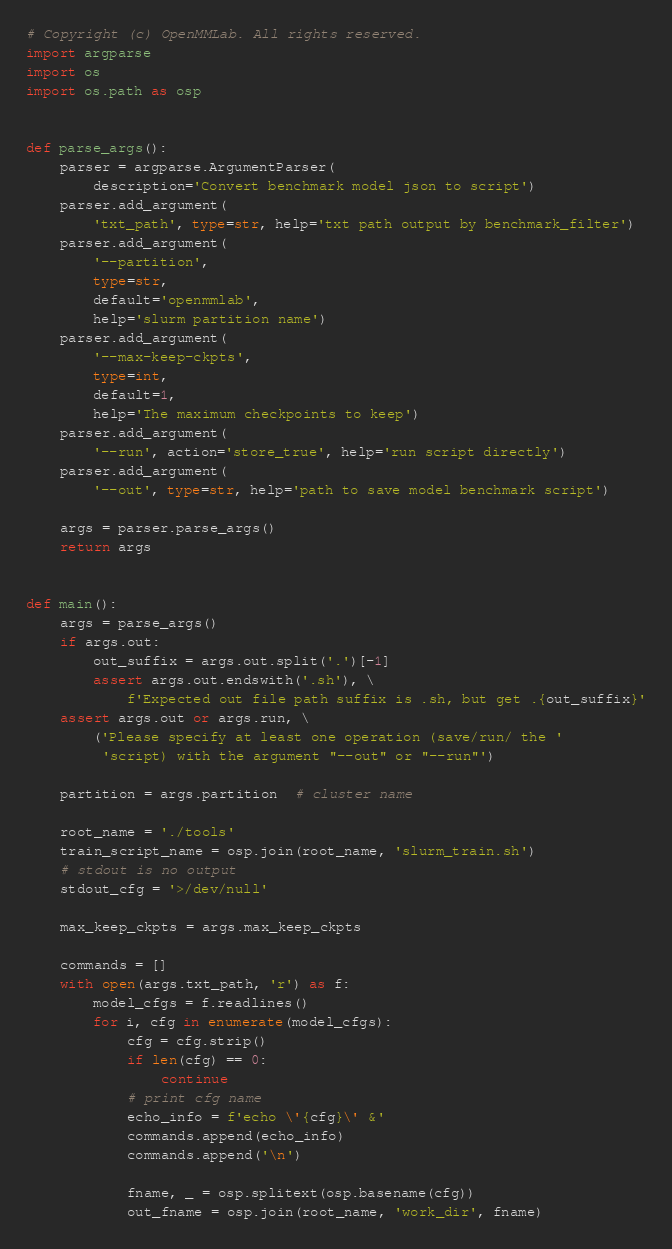<code> <loc_0><loc_0><loc_500><loc_500><_Python_># Copyright (c) OpenMMLab. All rights reserved.
import argparse
import os
import os.path as osp


def parse_args():
    parser = argparse.ArgumentParser(
        description='Convert benchmark model json to script')
    parser.add_argument(
        'txt_path', type=str, help='txt path output by benchmark_filter')
    parser.add_argument(
        '--partition',
        type=str,
        default='openmmlab',
        help='slurm partition name')
    parser.add_argument(
        '--max-keep-ckpts',
        type=int,
        default=1,
        help='The maximum checkpoints to keep')
    parser.add_argument(
        '--run', action='store_true', help='run script directly')
    parser.add_argument(
        '--out', type=str, help='path to save model benchmark script')

    args = parser.parse_args()
    return args


def main():
    args = parse_args()
    if args.out:
        out_suffix = args.out.split('.')[-1]
        assert args.out.endswith('.sh'), \
            f'Expected out file path suffix is .sh, but get .{out_suffix}'
    assert args.out or args.run, \
        ('Please specify at least one operation (save/run/ the '
         'script) with the argument "--out" or "--run"')

    partition = args.partition  # cluster name

    root_name = './tools'
    train_script_name = osp.join(root_name, 'slurm_train.sh')
    # stdout is no output
    stdout_cfg = '>/dev/null'

    max_keep_ckpts = args.max_keep_ckpts

    commands = []
    with open(args.txt_path, 'r') as f:
        model_cfgs = f.readlines()
        for i, cfg in enumerate(model_cfgs):
            cfg = cfg.strip()
            if len(cfg) == 0:
                continue
            # print cfg name
            echo_info = f'echo \'{cfg}\' &'
            commands.append(echo_info)
            commands.append('\n')

            fname, _ = osp.splitext(osp.basename(cfg))
            out_fname = osp.join(root_name, 'work_dir', fname)</code> 